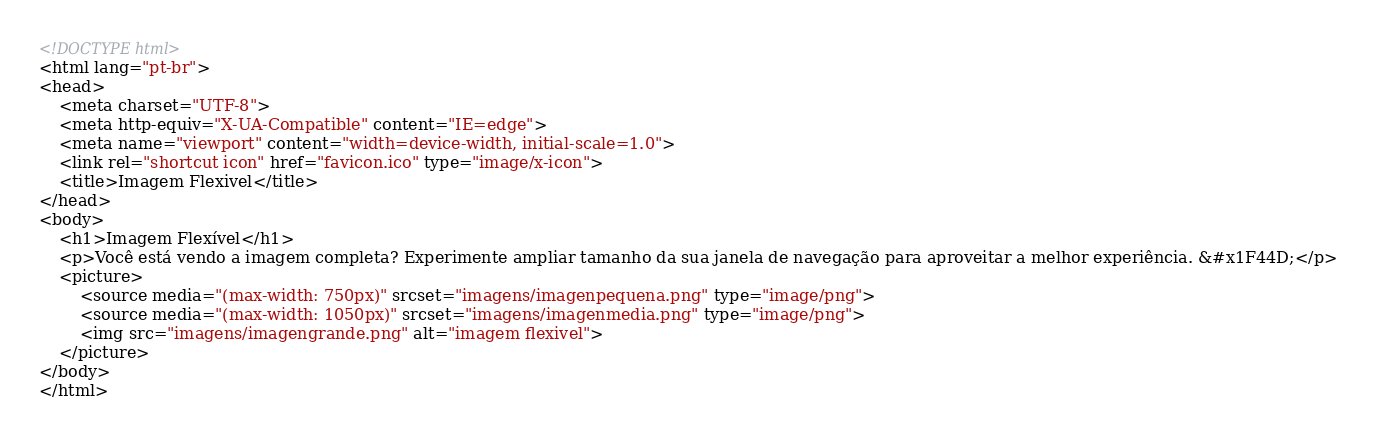Convert code to text. <code><loc_0><loc_0><loc_500><loc_500><_HTML_><!DOCTYPE html>
<html lang="pt-br">
<head>
    <meta charset="UTF-8">
    <meta http-equiv="X-UA-Compatible" content="IE=edge">
    <meta name="viewport" content="width=device-width, initial-scale=1.0">
    <link rel="shortcut icon" href="favicon.ico" type="image/x-icon">
    <title>Imagem Flexivel</title>
</head>
<body>
    <h1>Imagem Flexível</h1>
    <p>Você está vendo a imagem completa? Experimente ampliar tamanho da sua janela de navegação para aproveitar a melhor experiência. &#x1F44D;</p>
    <picture>
        <source media="(max-width: 750px)" srcset="imagens/imagenpequena.png" type="image/png">
        <source media="(max-width: 1050px)" srcset="imagens/imagenmedia.png" type="image/png">
        <img src="imagens/imagengrande.png" alt="imagem flexivel">
    </picture>
</body>
</html></code> 